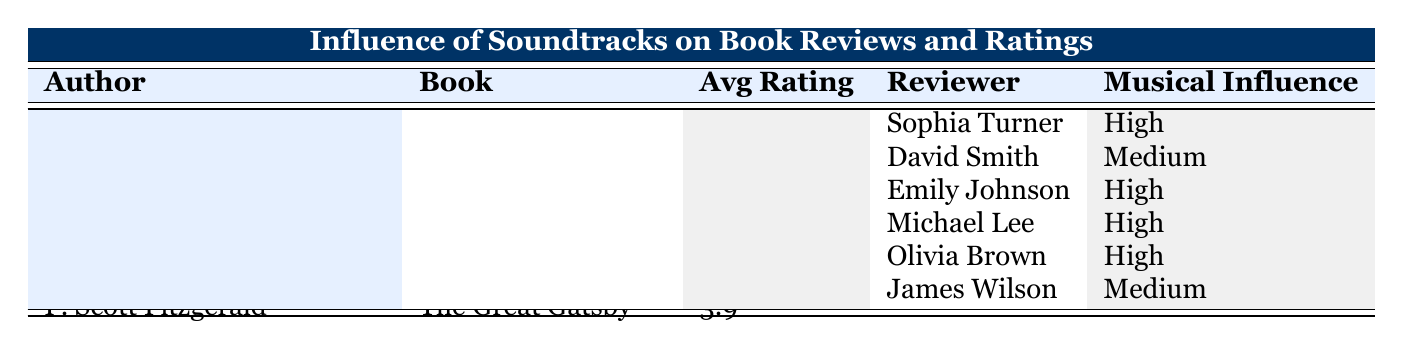What is the average rating of "Half of a Yellow Sun"? The average rating for "Half of a Yellow Sun" is listed in the table. It is found in the column labeled 'Avg Rating', corresponding to Chimamanda Ngozi Adichie's book. The value is 4.5.
Answer: 4.5 Which author has the highest average book rating? To determine which author has the highest average book rating, we compare the average ratings provided in the table: Haruki Murakami has 4.2, Chimamanda Ngozi Adichie has 4.5, and F. Scott Fitzgerald has 3.9. The highest average is 4.5, associated with Chimamanda Ngozi Adichie.
Answer: Chimamanda Ngozi Adichie How many reviews mention high musical influence for the book "The Great Gatsby"? The table lists the reviews for "The Great Gatsby" by F. Scott Fitzgerald. There are two reviews: one by Olivia Brown, which states "High", and one by James Wilson, which states "Medium". Therefore, only one review mentions high musical influence.
Answer: 1 Is there a review for "Norwegian Wood" that states medium musical influence? The reviews for "Norwegian Wood" indicate two different musical influences. Sophia Turner's review states "High" while David Smith's review states "Medium". This confirms that there is indeed at least one review with medium musical influence.
Answer: Yes What is the total number of reviews across all books? To find the total number of reviews, we sum up the reviews for each book: "Norwegian Wood" has 2 reviews, "Half of a Yellow Sun" has 2 reviews, and "The Great Gatsby" has 2 reviews. Therefore, total reviews = 2 + 2 + 2 = 6.
Answer: 6 Which reviewer mentioned that the classical soundtrack elevated emotional depth in "Norwegian Wood"? By examining the review text associated with “Norwegian Wood”, David Smith specifically mentions the emotional depth being elevated by classical music. Therefore, he is the reviewer who noted this aspect.
Answer: David Smith What is the average rating of books with high musical influence only? For this calculation, we first identify the books that received high musical influence: "Norwegian Wood" (4.2), "Half of a Yellow Sun" (4.5), and "The Great Gatsby" (3.9). The average rating is calculated as follows: (4.2 + 4.5 + 3.9) / 3 = 4.2.
Answer: 4.2 Who wrote a review stating that the jazz soundtrack brings the Roaring Twenties to life? The review that highlights the impact of the jazz soundtrack on the setting of "The Great Gatsby" is from Olivia Brown. The text specifically notes that the jazz soundtrack brings the era to life.
Answer: Olivia Brown 